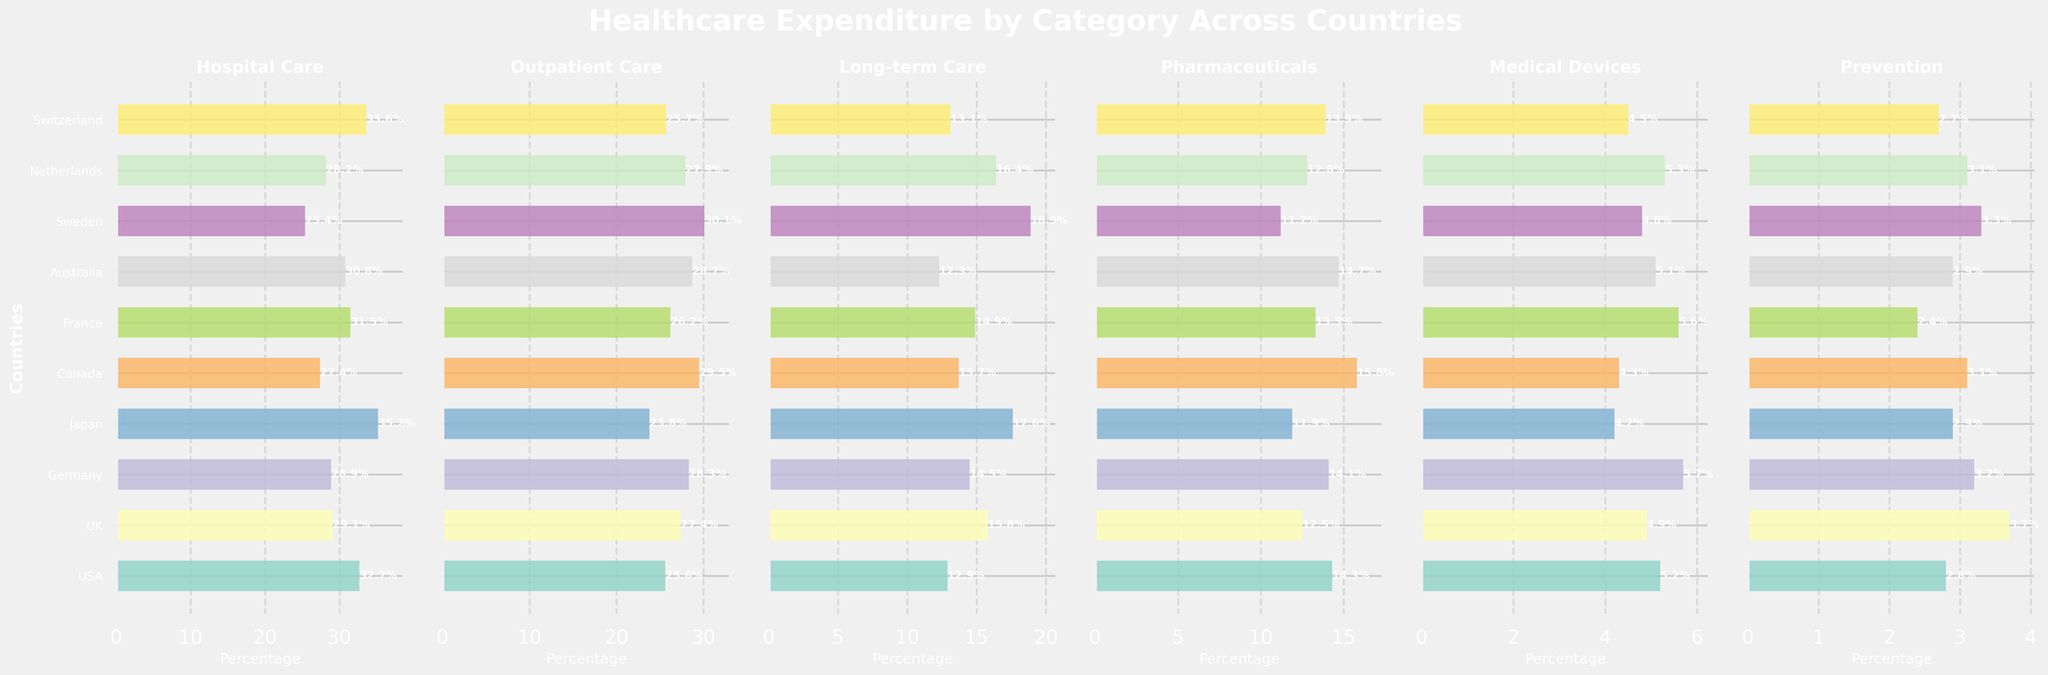Which country spends the most on Hospital Care? By looking at the subplot for "Hospital Care," the USA has the longest bar, indicating the highest expenditure percentage.
Answer: USA Which category does Sweden spend the most on? By looking at Sweden's bars across all subplots, the longest bar is in "Long-term Care."
Answer: Long-term Care What's the total percentage expenditure on Pharmaceuticals and Medical Devices in Canada? Check the lengths of the bars for Pharmaceuticals and Medical Devices in the Canada row: 15.8% and 4.3%, respectively. Sum these values: 15.8 + 4.3 = 20.1%
Answer: 20.1% Which country has the lowest expenditure on Prevention? Check the subplot for "Prevention" and find the shortest bar. France has the shortest bar for "Prevention."
Answer: France How does the expenditure on Outpatient Care in Japan compare to Germany? Looking at the "Outpatient Care" subplot, Japan's bar is at 23.8%, and Germany's is at 28.3%. 23.8% is less than 28.3%.
Answer: Japan spends less Is the expenditure on Medical Devices in Canada more than that in Switzerland? Comparing the "Medical Devices" bars, Canada has 4.3% and Switzerland has 4.5%. 4.3% is less than 4.5%.
Answer: No What's the difference in expenditure on Long-term Care between Sweden and the UK? The expenditure percentages for "Long-term Care" are 18.9% (Sweden) and 15.8% (UK). Calculate the difference: 18.9 - 15.8 = 3.1%
Answer: 3.1% What is the average expenditure percentage on Pharmaceuticals across the USA, UK, and Germany? Look at the "Pharmaceuticals" subplot and find the percentages: 14.3% (USA), 12.5% (UK), and 14.1% (Germany). Calculate the average: (14.3 + 12.5 + 14.1) / 3 = 13.63%
Answer: 13.63% Which country spends the most on Medical Devices? By observing the "Medical Devices" subplot, Germany has the longest bar, indicating the highest expenditure percentage.
Answer: Germany Does Australia spend more on Outpatient Care or Hospital Care? Compare the "Outpatient Care" and "Hospital Care" bars for Australia. Outpatient Care is 28.7% and Hospital Care is 30.8%. 30.8% is greater than 28.7%.
Answer: Hospital Care 